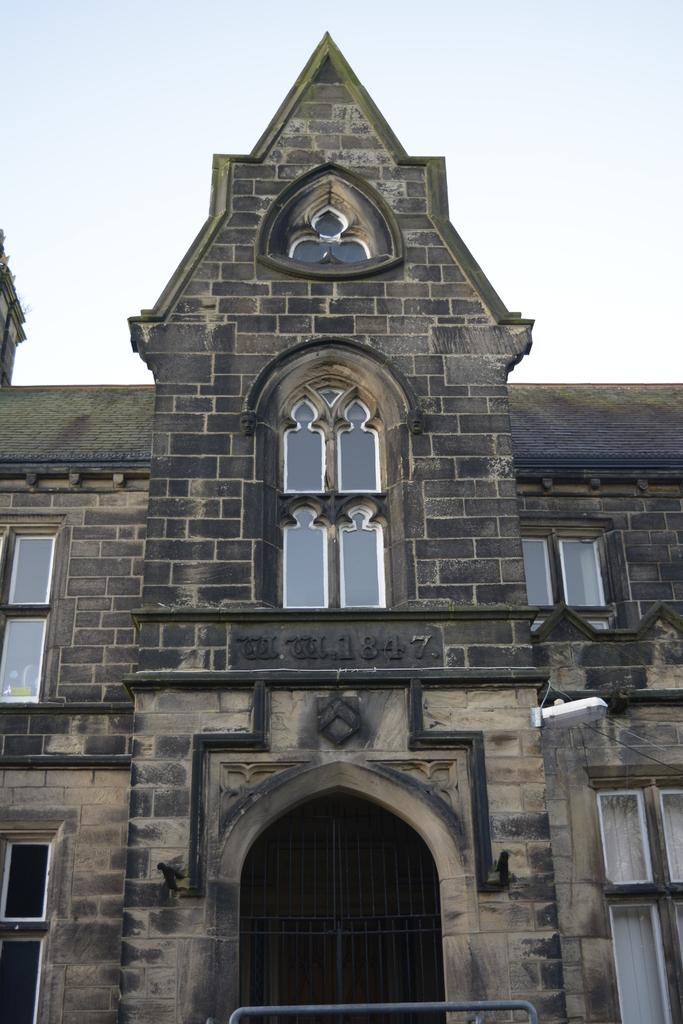What is the main subject of the picture? The main subject of the picture is a building. What specific features can be seen on the building? The building has windows and doors. What can be seen in the background of the picture? The sky is visible in the background of the picture. What type of creature is depicted on the building's authority symbol in the image? There is no authority symbol or creature present on the building in the image. How many nails can be seen holding the building together in the image? There are no nails visible in the image, as the building's construction is not shown in detail. 